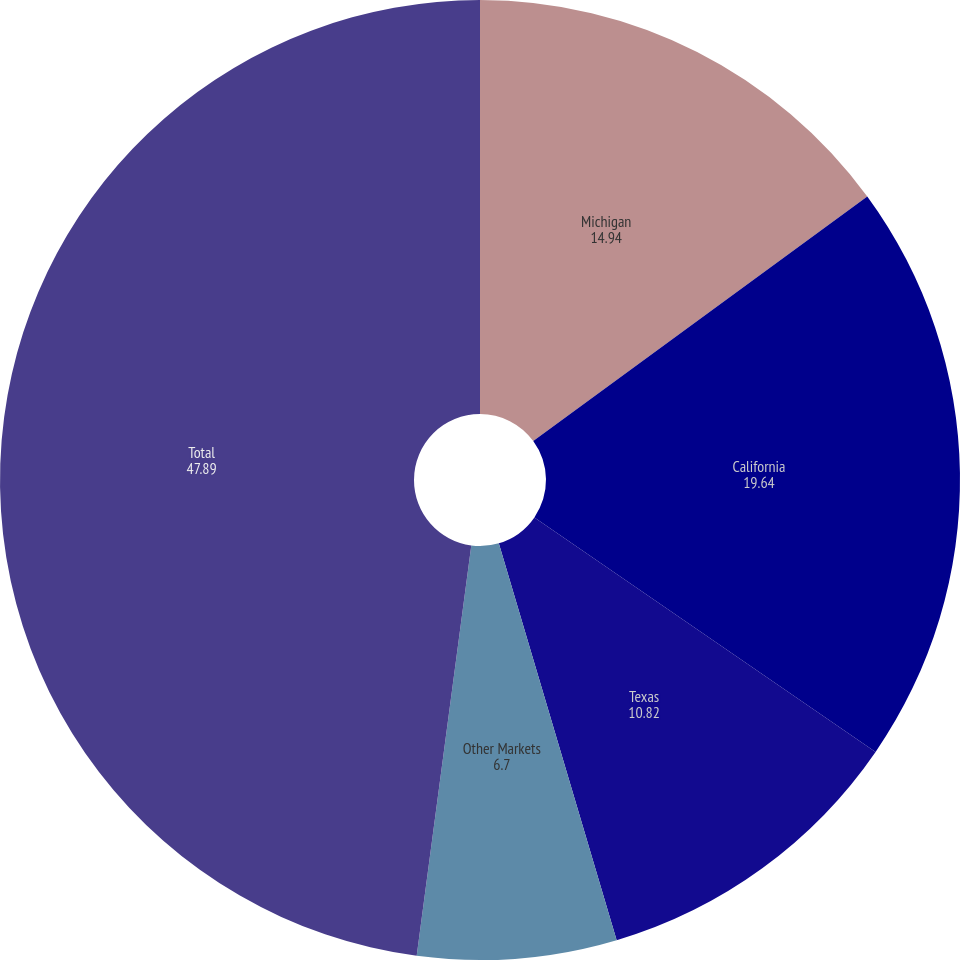Convert chart. <chart><loc_0><loc_0><loc_500><loc_500><pie_chart><fcel>Michigan<fcel>California<fcel>Texas<fcel>Other Markets<fcel>Total<nl><fcel>14.94%<fcel>19.64%<fcel>10.82%<fcel>6.7%<fcel>47.89%<nl></chart> 